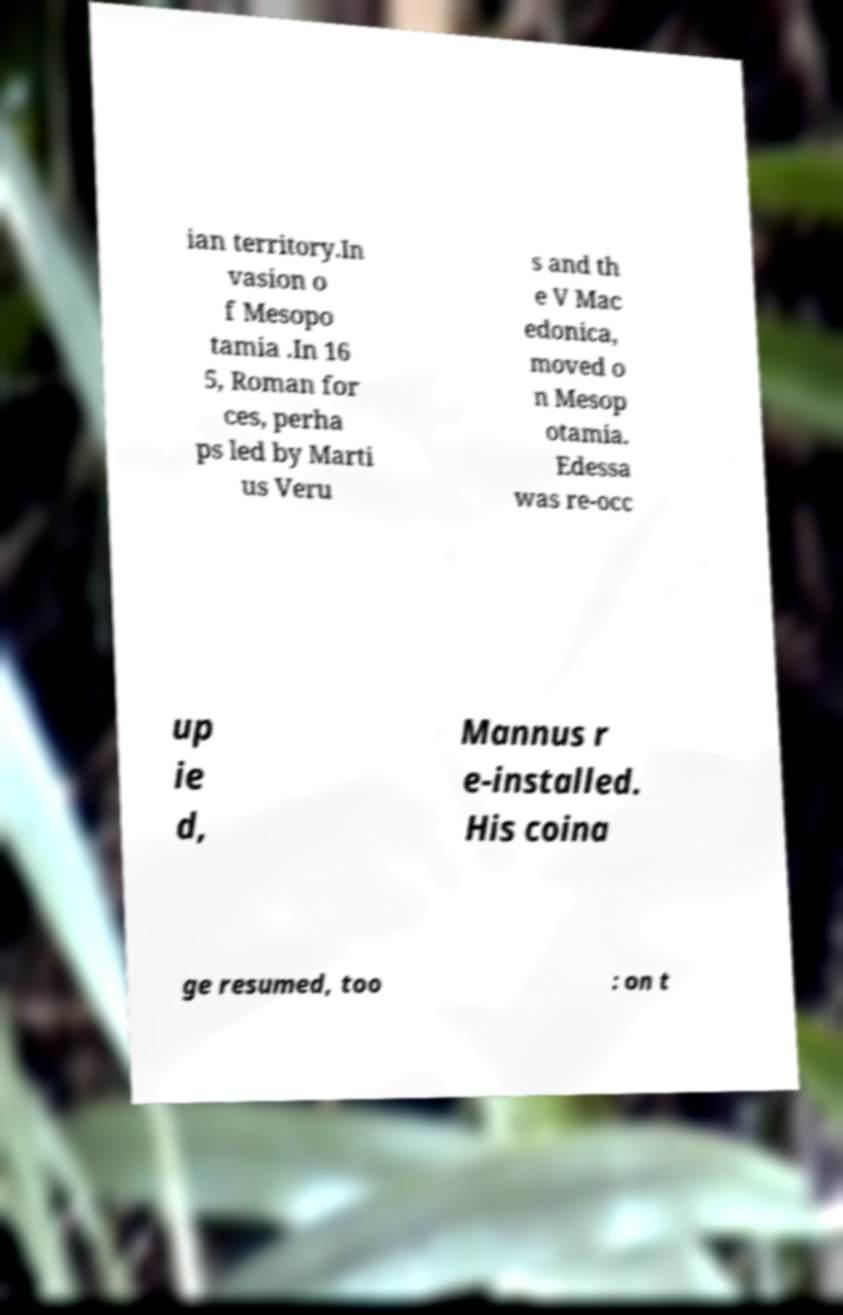Please read and relay the text visible in this image. What does it say? ian territory.In vasion o f Mesopo tamia .In 16 5, Roman for ces, perha ps led by Marti us Veru s and th e V Mac edonica, moved o n Mesop otamia. Edessa was re-occ up ie d, Mannus r e-installed. His coina ge resumed, too : on t 